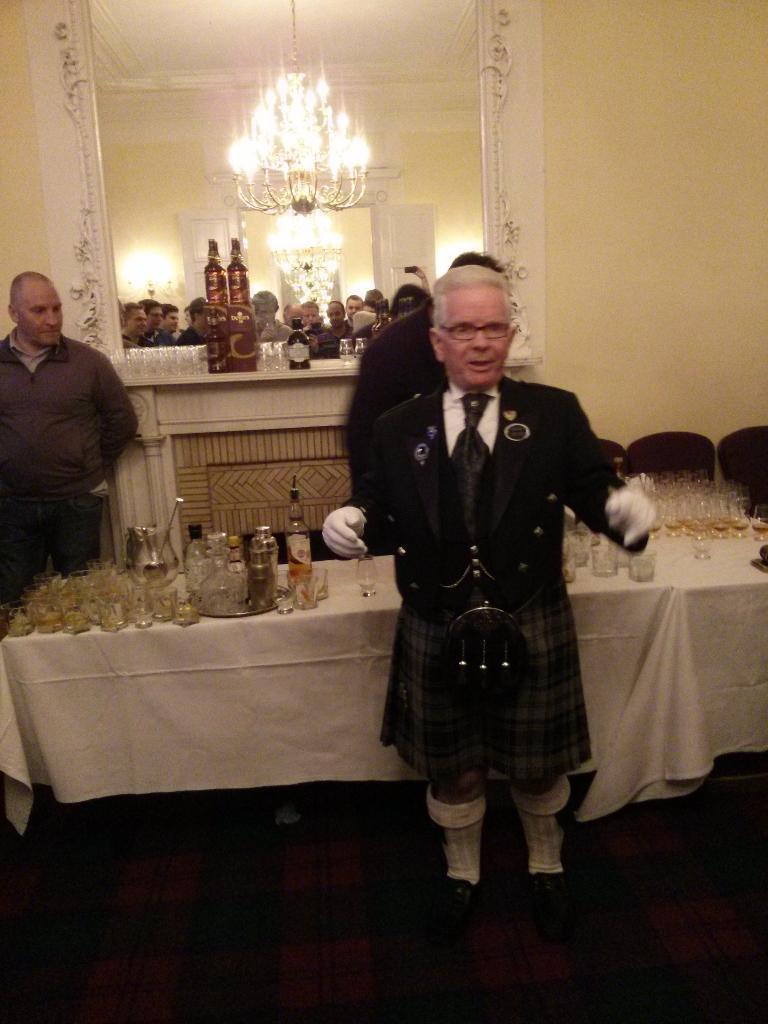How would you summarize this image in a sentence or two? This image is clicked in a room. There is a man standing in the middle who is wearing a black dress black shoes and white socks with black tie. He also has Glouses to his hands. He wears specs and there is a man on the left side corner ,there is a table in the middle of the image, where there are so many glasses and bottles on that table there is a white cloth on the table on the top there is light lamp. There is a big Mirror on the top where we can see the people in front of them 